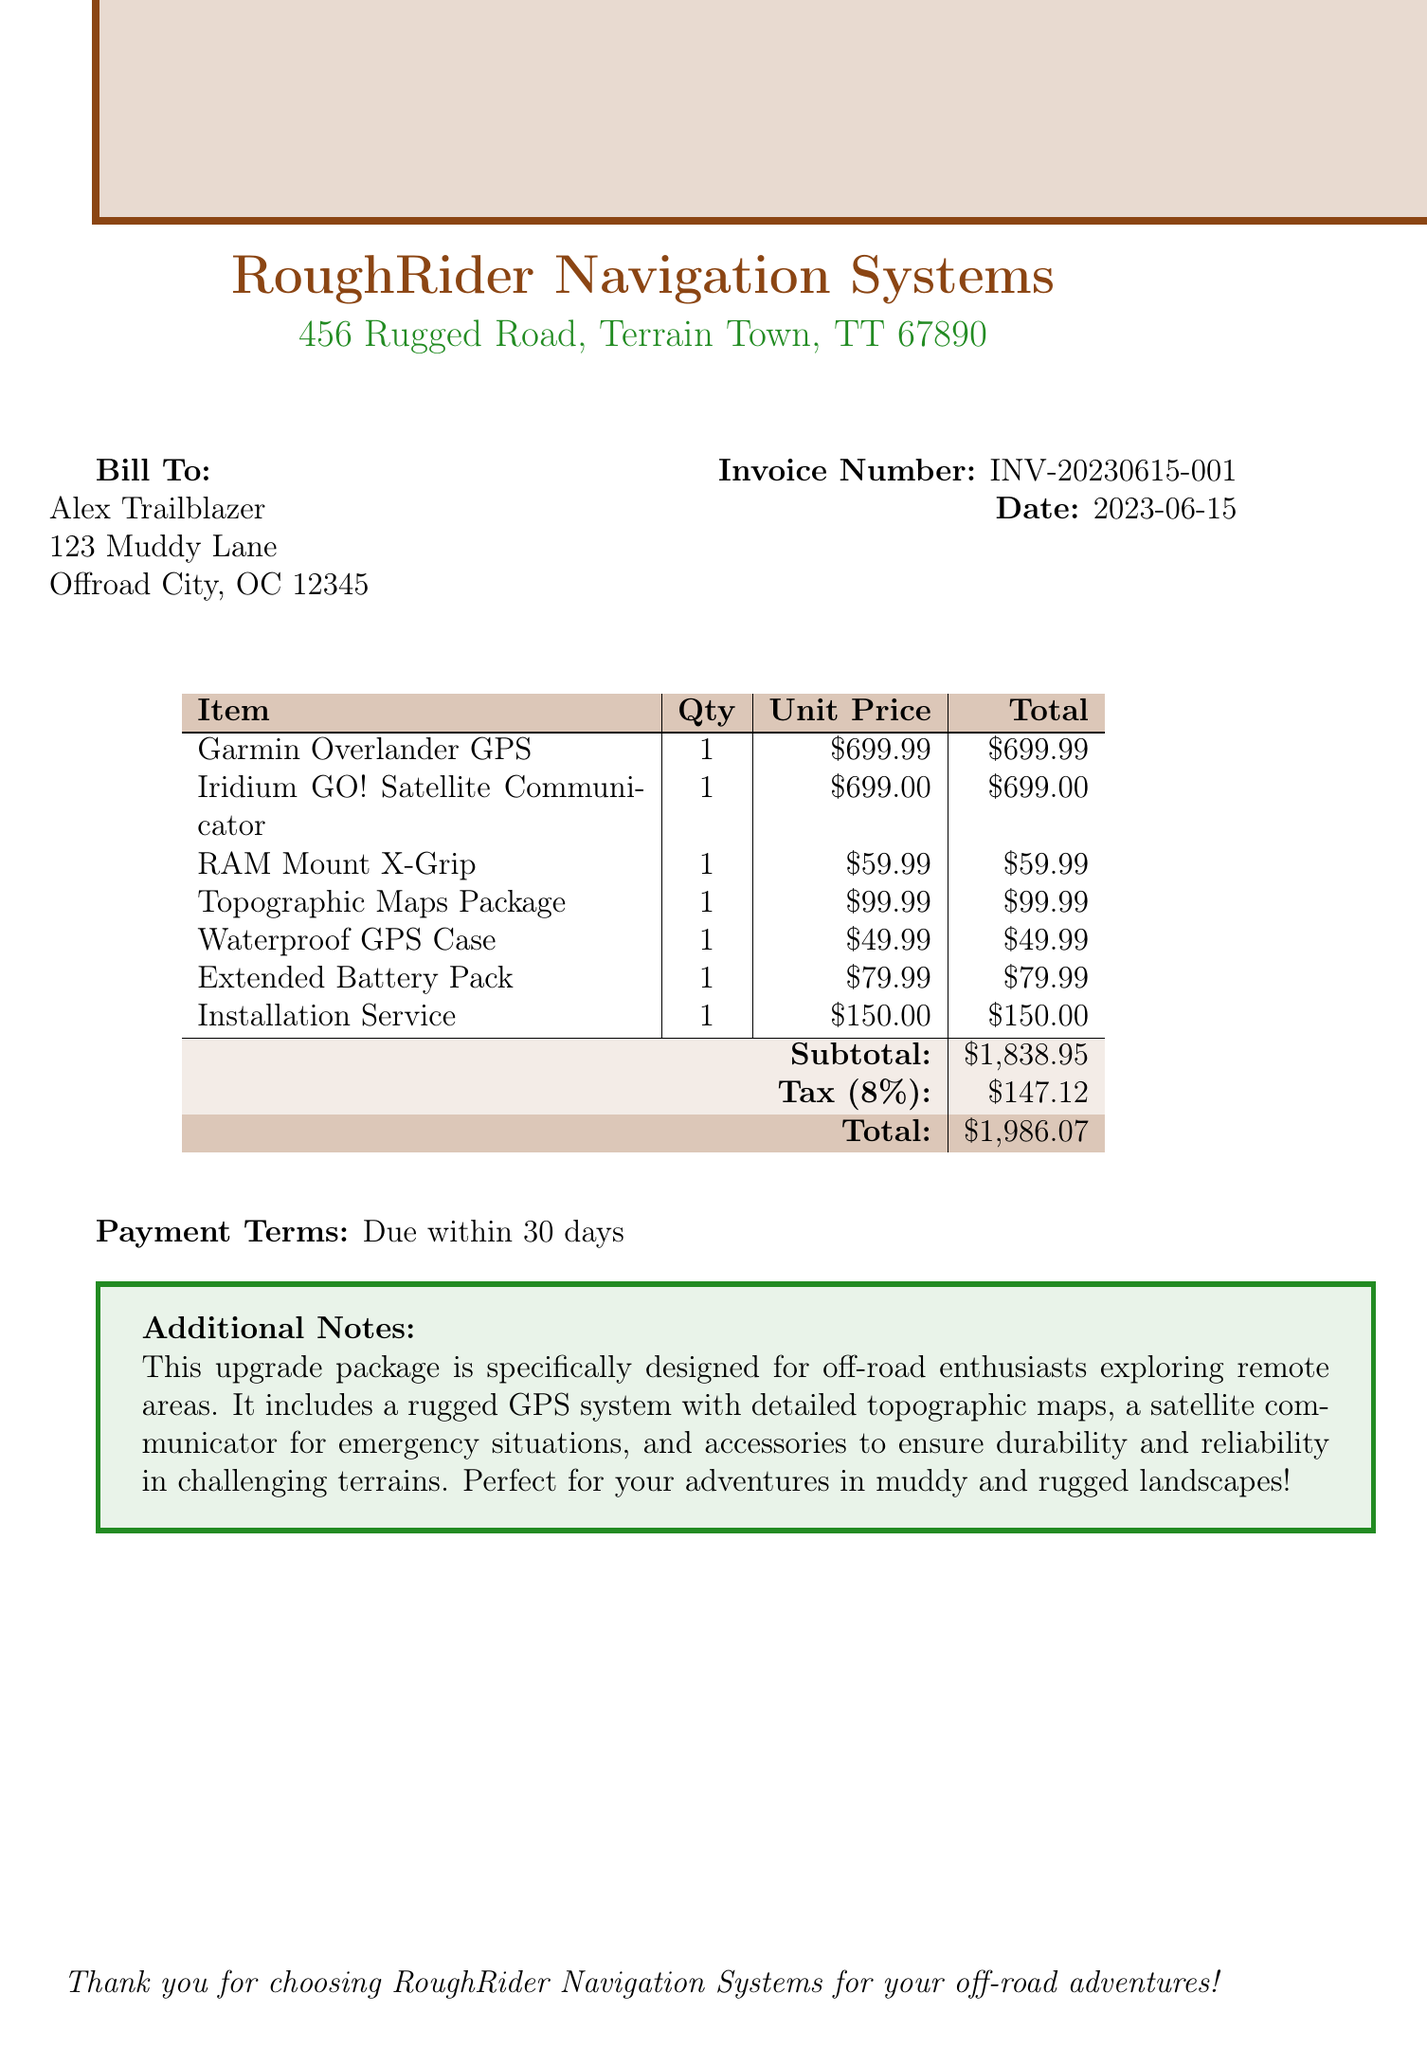what is the invoice number? The invoice number is a unique identifier for the transaction, which is provided in the document.
Answer: INV-20230615-001 who is the customer? The document lists the person who has made the purchase, which is shown in the billing section.
Answer: Alex Trailblazer what is the total amount due? The total amount is the final charge that includes all items, taxes, and fees as stated in the document.
Answer: 1986.07 what is the tax rate applied? The tax rate is specified in the document, representing the percentage of tax applied to the subtotal.
Answer: 8 percent what items are included in the installation service? This inquiry looks for the item strings that encompass the services provided as mentioned in the document.
Answer: GPS and satellite communicator what accessory is used to protect the GPS? The document describes this item as part of the package that ensures the GPS's durability in rugged conditions.
Answer: Waterproof GPS Case how much does the Garmin Overlander GPS cost? The price of a specific item in the invoice reflects its individual cost as listed.
Answer: 699.99 what additional feature does the Iridium GO! provide? The document mentions this item as a satellite communicator with specific capabilities.
Answer: Global communication when is the payment due? The document notes this as part of the payment terms provided at the bottom of the invoice.
Answer: Due within 30 days 